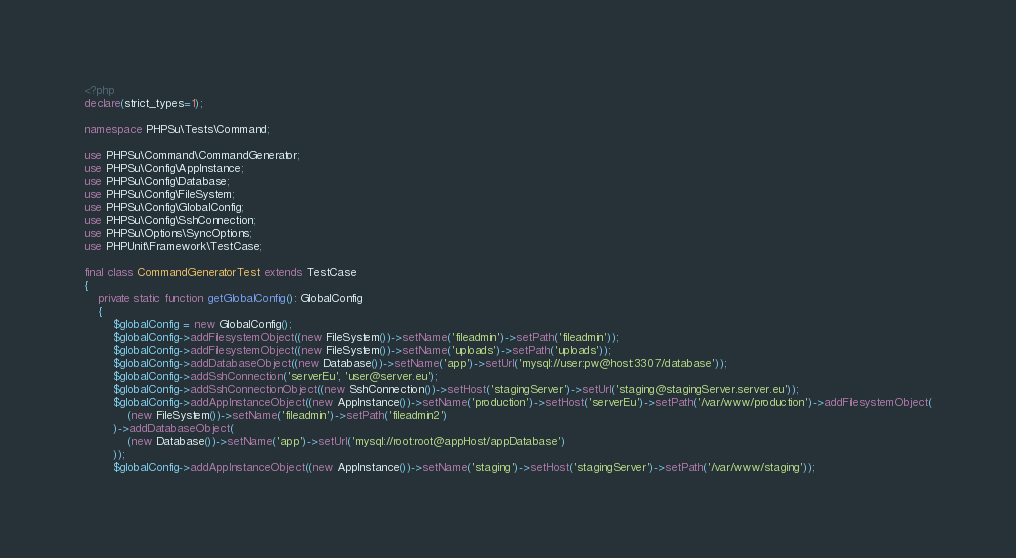<code> <loc_0><loc_0><loc_500><loc_500><_PHP_><?php
declare(strict_types=1);

namespace PHPSu\Tests\Command;

use PHPSu\Command\CommandGenerator;
use PHPSu\Config\AppInstance;
use PHPSu\Config\Database;
use PHPSu\Config\FileSystem;
use PHPSu\Config\GlobalConfig;
use PHPSu\Config\SshConnection;
use PHPSu\Options\SyncOptions;
use PHPUnit\Framework\TestCase;

final class CommandGeneratorTest extends TestCase
{
    private static function getGlobalConfig(): GlobalConfig
    {
        $globalConfig = new GlobalConfig();
        $globalConfig->addFilesystemObject((new FileSystem())->setName('fileadmin')->setPath('fileadmin'));
        $globalConfig->addFilesystemObject((new FileSystem())->setName('uploads')->setPath('uploads'));
        $globalConfig->addDatabaseObject((new Database())->setName('app')->setUrl('mysql://user:pw@host:3307/database'));
        $globalConfig->addSshConnection('serverEu', 'user@server.eu');
        $globalConfig->addSshConnectionObject((new SshConnection())->setHost('stagingServer')->setUrl('staging@stagingServer.server.eu'));
        $globalConfig->addAppInstanceObject((new AppInstance())->setName('production')->setHost('serverEu')->setPath('/var/www/production')->addFilesystemObject(
            (new FileSystem())->setName('fileadmin')->setPath('fileadmin2')
        )->addDatabaseObject(
            (new Database())->setName('app')->setUrl('mysql://root:root@appHost/appDatabase')
        ));
        $globalConfig->addAppInstanceObject((new AppInstance())->setName('staging')->setHost('stagingServer')->setPath('/var/www/staging'));</code> 